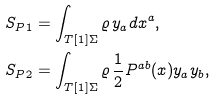<formula> <loc_0><loc_0><loc_500><loc_500>S _ { P 1 } & = \int _ { T [ 1 ] \Sigma } \varrho \, y _ { a } d x ^ { a } , \\ S _ { P 2 } & = \int _ { T [ 1 ] \Sigma } \varrho \, \frac { 1 } { 2 } P ^ { a b } ( x ) y _ { a } y _ { b } ,</formula> 